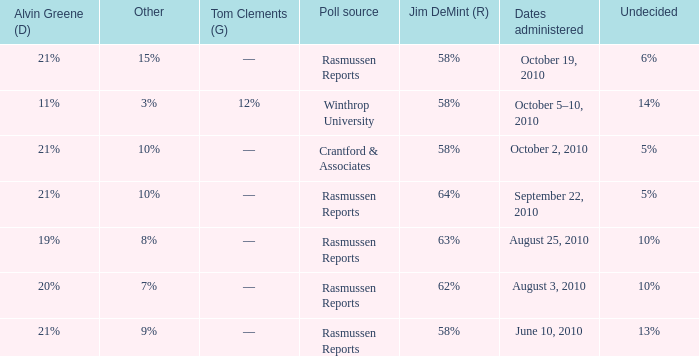Which poll source determined undecided of 5% and Jim DeMint (R) of 58%? Crantford & Associates. 